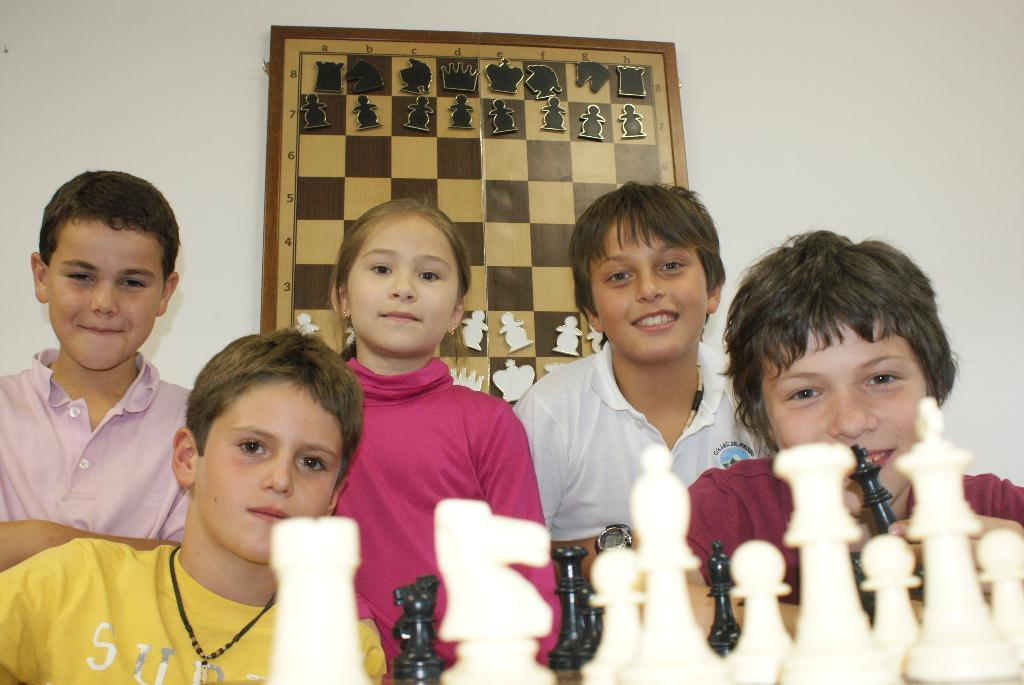Who is present in the image? There are kids in the image. What activity are the kids engaged in? The kids are playing with a chess board in the image. What can be seen on the wall in the background? There is a white wall in the background of the image. Is there any chess-related item on the wall? Yes, there is a chess board photo frame on the wall. What type of air can be seen in the image? There is no air visible in the image; it is a still photograph. What trick are the kids performing with the chess board? There is no trick being performed in the image; the kids are simply playing with the chess board. 